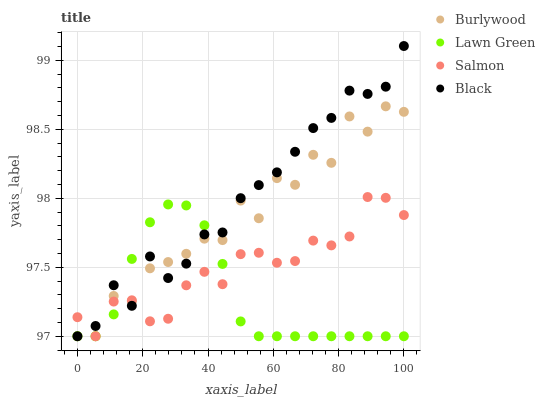Does Lawn Green have the minimum area under the curve?
Answer yes or no. Yes. Does Black have the maximum area under the curve?
Answer yes or no. Yes. Does Salmon have the minimum area under the curve?
Answer yes or no. No. Does Salmon have the maximum area under the curve?
Answer yes or no. No. Is Lawn Green the smoothest?
Answer yes or no. Yes. Is Burlywood the roughest?
Answer yes or no. Yes. Is Salmon the smoothest?
Answer yes or no. No. Is Salmon the roughest?
Answer yes or no. No. Does Burlywood have the lowest value?
Answer yes or no. Yes. Does Black have the highest value?
Answer yes or no. Yes. Does Salmon have the highest value?
Answer yes or no. No. Does Salmon intersect Burlywood?
Answer yes or no. Yes. Is Salmon less than Burlywood?
Answer yes or no. No. Is Salmon greater than Burlywood?
Answer yes or no. No. 